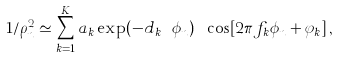Convert formula to latex. <formula><loc_0><loc_0><loc_500><loc_500>1 / \rho ^ { 2 } _ { n } \simeq \sum _ { k = 1 } ^ { K } a _ { k } \exp ( - d _ { k } \ \phi _ { n } ) \ \cos [ 2 \pi f _ { k } \phi _ { n } + \varphi _ { k } ] \, ,</formula> 